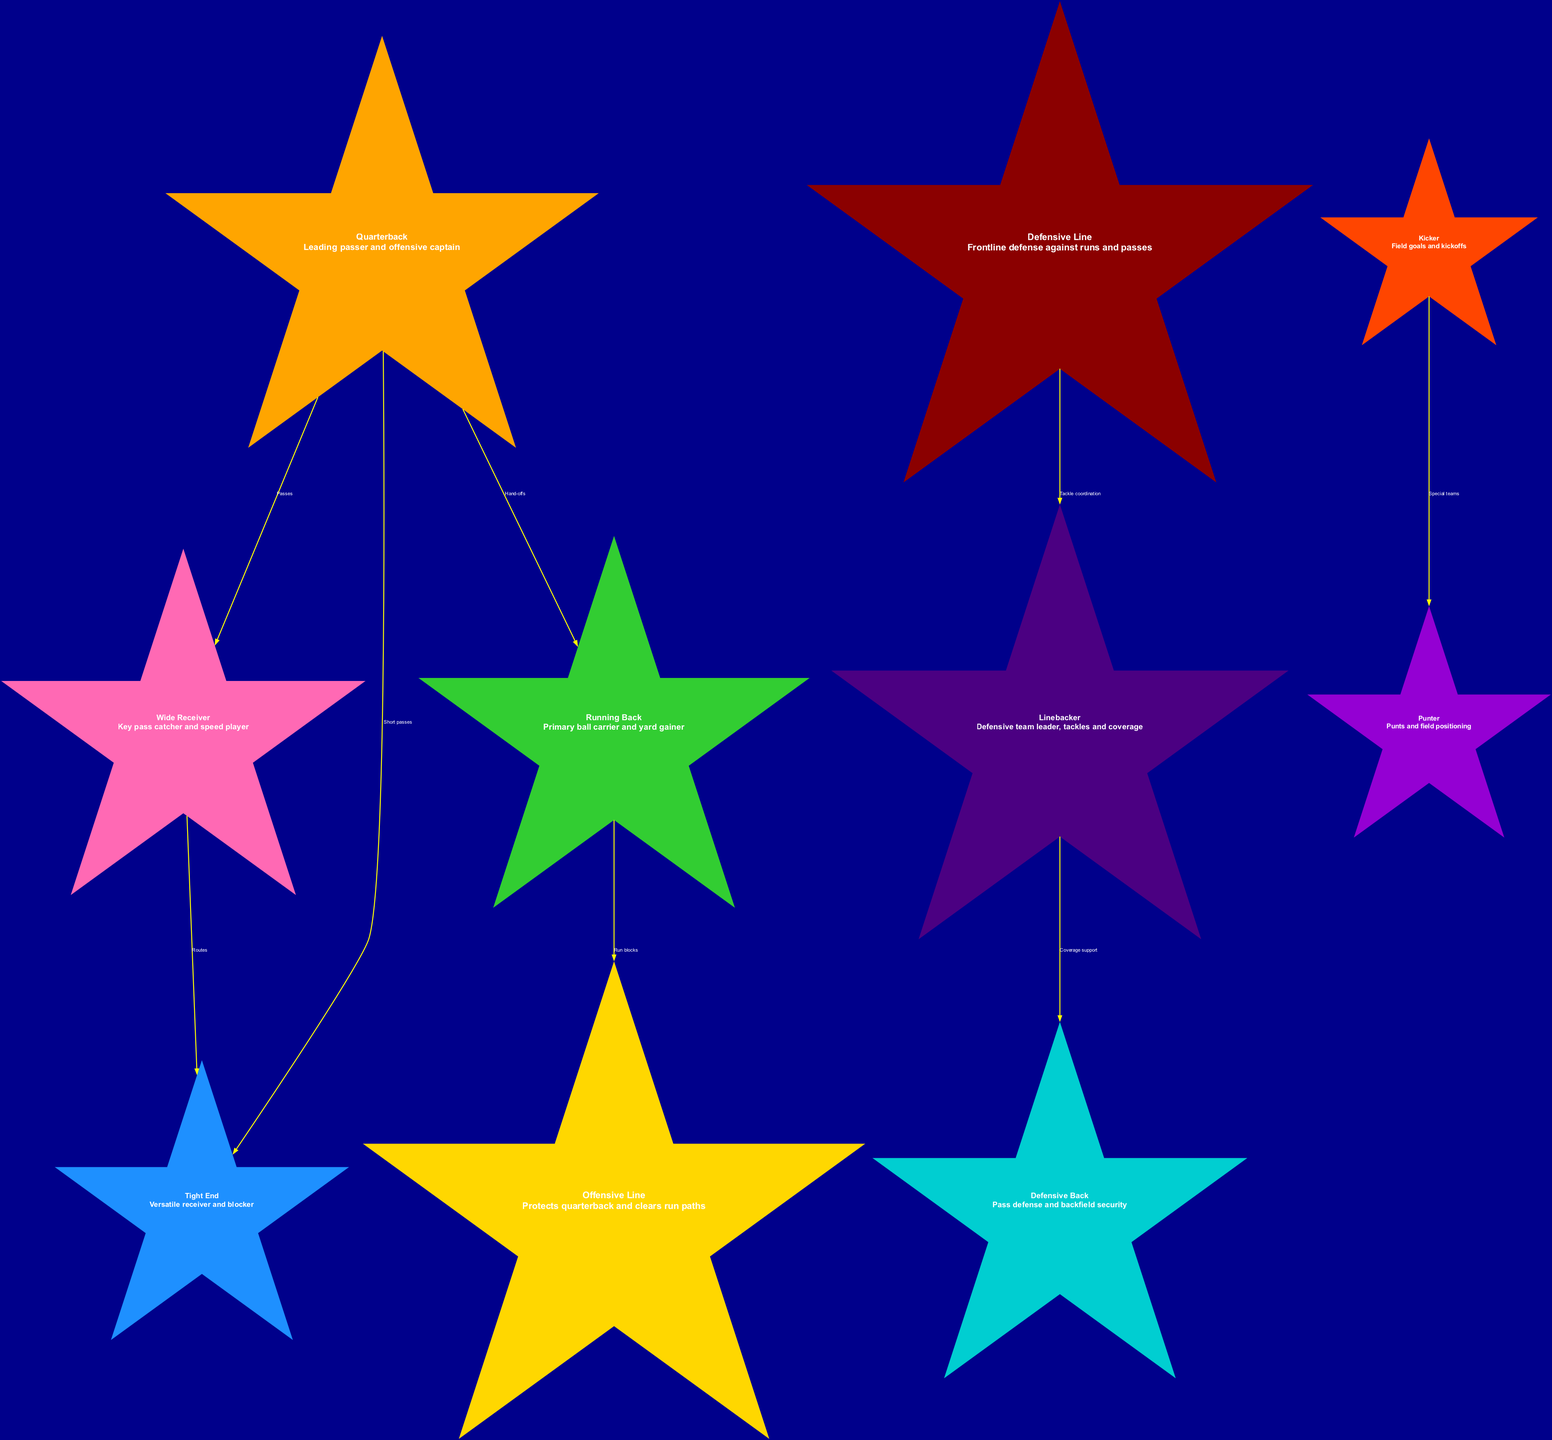What is the node with the largest star size? The node sizes represent the significance of each position, and the largest size corresponds to the Offensive Line and Defensive Line, which both have a star size of 9.
Answer: Offensive Line, Defensive Line How many total nodes are there in the diagram? By counting all the unique positions listed in the nodes section, there are a total of 10 different positions represented.
Answer: 10 Which position is responsible for "Passes"? Looking at the edges, the "Passes" relationship originates from the Quarterback node, indicating the position that primarily handles passing plays.
Answer: Quarterback How many edges are there connecting the nodes? Each edge in the diagram represents a relationship, and by counting the connections listed in the edges section, there are a total of 8 edges connecting various positions.
Answer: 8 Which two positions have a direct relationship involving "Special teams"? The edge related to "Special teams" connects the Kicker and Punter nodes, indicating their linked roles in that aspect of the game.
Answer: Kicker, Punter How does the Offensive Line contribute to play effectiveness? The edges show that the Offensive Line supports the Running Back by providing run blocks, which directly aids in advancing the ball and protecting the quarterback.
Answer: Run blocks Which position has the lowest star size? The smallest star size in the diagram is attributed to both the Kicker and Punter positions, both of which have a star size of 4.
Answer: Kicker, Punter What is the relationship between Linebackers and Defensive Backs? The edge indicates that Linebackers provide coverage support to Defensive Backs, suggesting a collaborative defensive strategy in tackling and preventing pass plays.
Answer: Coverage support 